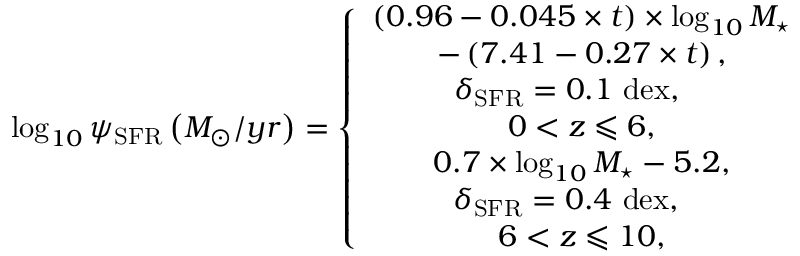<formula> <loc_0><loc_0><loc_500><loc_500>\log _ { 1 0 } \psi _ { S F R } \left ( M _ { \odot } / y r \right ) = \left \{ \begin{array} { c } { \left ( 0 . 9 6 - 0 . 0 4 5 \times t \right ) \times \log _ { 1 0 } M _ { ^ { * } } } \\ { - \left ( 7 . 4 1 - 0 . 2 7 \times t \right ) , } \\ { \delta _ { S F R } = 0 . 1 d e x , \quad } \\ { { 0 < z \leqslant 6 } , } \\ { 0 . 7 \times \log _ { 1 0 } M _ { ^ { * } } - 5 . 2 , } \\ { \, \delta _ { S F R } = 0 . 4 d e x , \quad } \\ { { 6 < z \leqslant 1 0 } , } \end{array}</formula> 